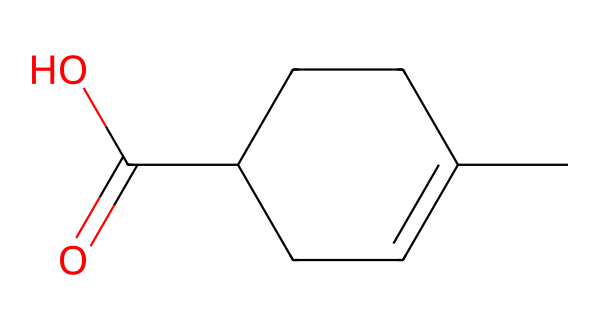What is the primary functional group in this chemical? The chemical structure contains a carboxylic acid functional group, indicated by the presence of the carbon atom double-bonded to an oxygen atom and single-bonded to a hydroxyl group (C(=O)O).
Answer: carboxylic acid How many carbon atoms are present in this molecule? The SMILES representation indicates a total of six carbon atoms in the cyclic ring and one in the carboxylic group, making a total of seven carbon atoms.
Answer: seven What is the molecular formula for this compound? By counting the elements from the structure, we can derive the molecular formula: C7H12O2, which corresponds to seven carbon, twelve hydrogen, and two oxygen atoms.
Answer: C7H12O2 What type of isomerism might this chemical exhibit? Given the presence of a ring and a functional group, this compound can show structural isomerism, specifically positional isomerism related to the location of the carboxylic acid on the cycloalkane.
Answer: structural isomerism What is the expected state of this chemical at room temperature? Considering its molecular structure which features a low molecular weight and a carboxylic acid group, it is likely to be a liquid at room temperature.
Answer: liquid Which herb commonly produces this type of essential oil in Tamil Nadu? Various indigenous Tamil herbs like mustard can yield essential oil with similar molecular characteristics to this compound.
Answer: mustard 